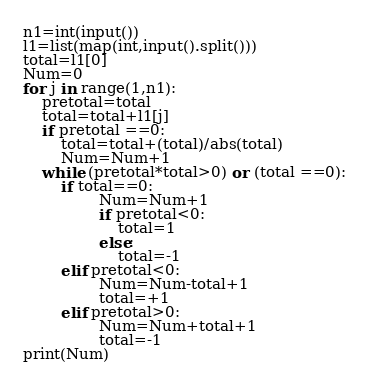Convert code to text. <code><loc_0><loc_0><loc_500><loc_500><_Python_>n1=int(input())
l1=list(map(int,input().split()))
total=l1[0]
Num=0
for j in range(1,n1):
    pretotal=total
    total=total+l1[j]
    if pretotal ==0:
        total=total+(total)/abs(total)
        Num=Num+1
    while (pretotal*total>0) or (total ==0):
        if total==0:
                Num=Num+1
                if pretotal<0:
                    total=1
                else:
                    total=-1
        elif pretotal<0:
                Num=Num-total+1
                total=+1
        elif pretotal>0:
                Num=Num+total+1
                total=-1
print(Num)</code> 